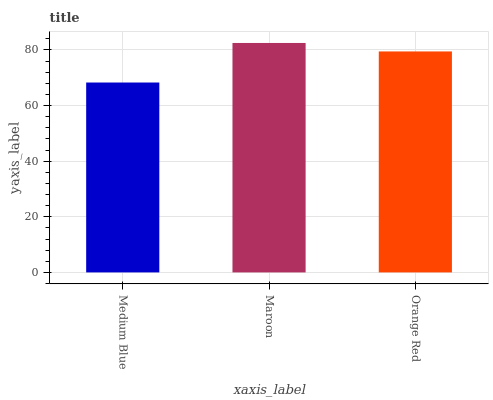Is Medium Blue the minimum?
Answer yes or no. Yes. Is Maroon the maximum?
Answer yes or no. Yes. Is Orange Red the minimum?
Answer yes or no. No. Is Orange Red the maximum?
Answer yes or no. No. Is Maroon greater than Orange Red?
Answer yes or no. Yes. Is Orange Red less than Maroon?
Answer yes or no. Yes. Is Orange Red greater than Maroon?
Answer yes or no. No. Is Maroon less than Orange Red?
Answer yes or no. No. Is Orange Red the high median?
Answer yes or no. Yes. Is Orange Red the low median?
Answer yes or no. Yes. Is Medium Blue the high median?
Answer yes or no. No. Is Maroon the low median?
Answer yes or no. No. 